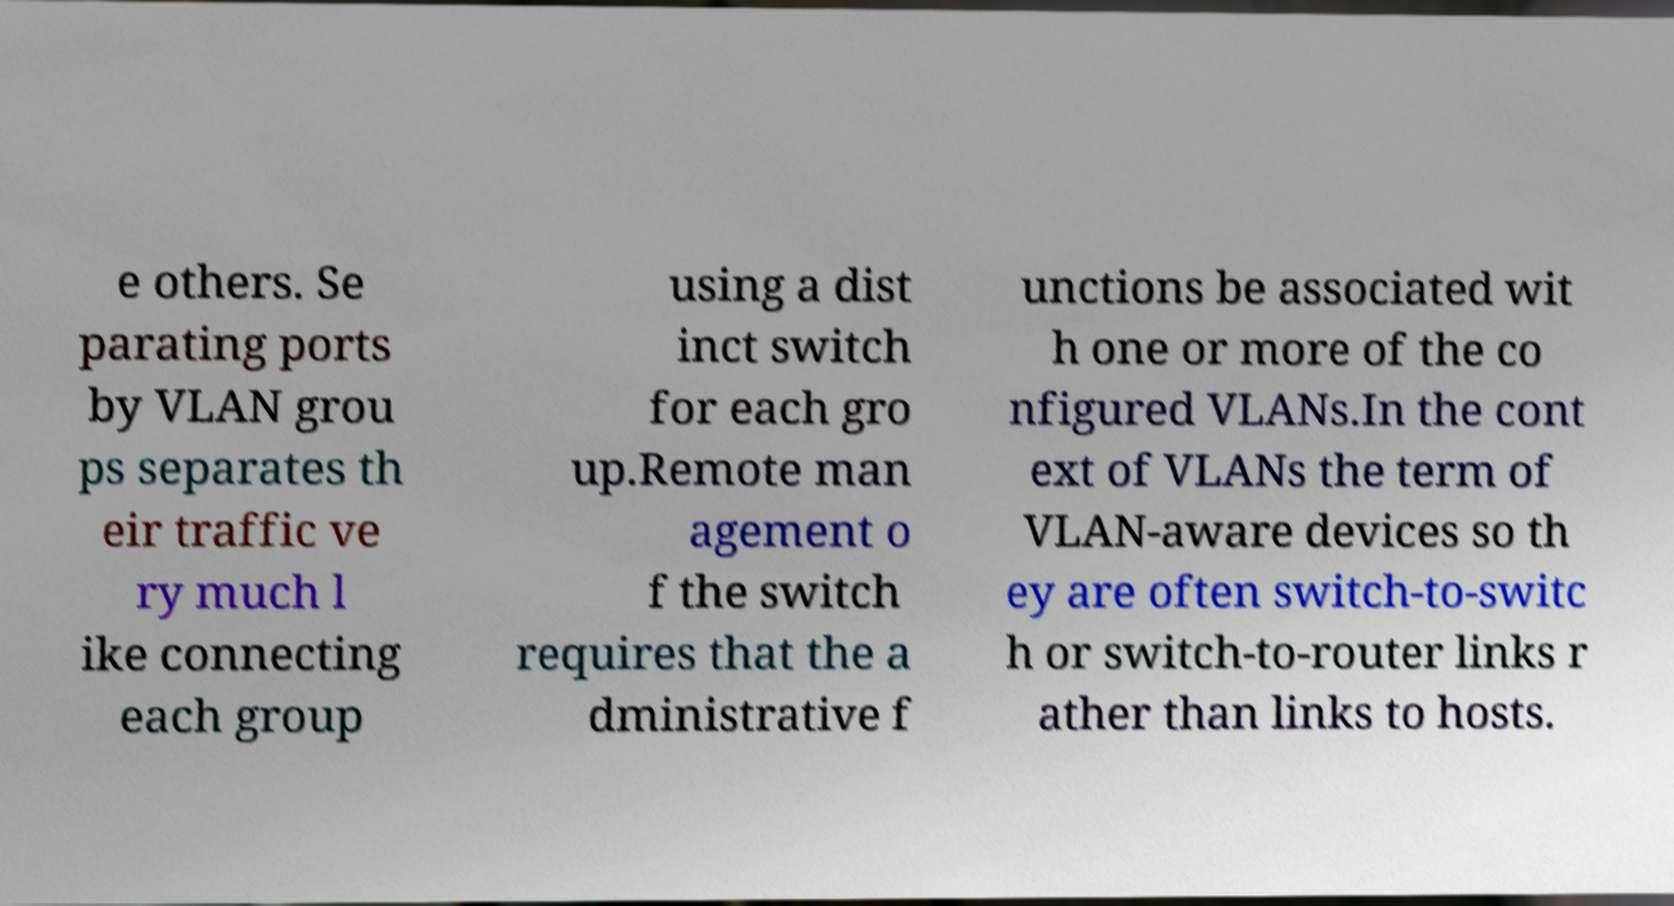Can you accurately transcribe the text from the provided image for me? e others. Se parating ports by VLAN grou ps separates th eir traffic ve ry much l ike connecting each group using a dist inct switch for each gro up.Remote man agement o f the switch requires that the a dministrative f unctions be associated wit h one or more of the co nfigured VLANs.In the cont ext of VLANs the term of VLAN-aware devices so th ey are often switch-to-switc h or switch-to-router links r ather than links to hosts. 